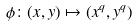Convert formula to latex. <formula><loc_0><loc_0><loc_500><loc_500>\phi \colon ( x , y ) \mapsto ( x ^ { q } , y ^ { q } )</formula> 